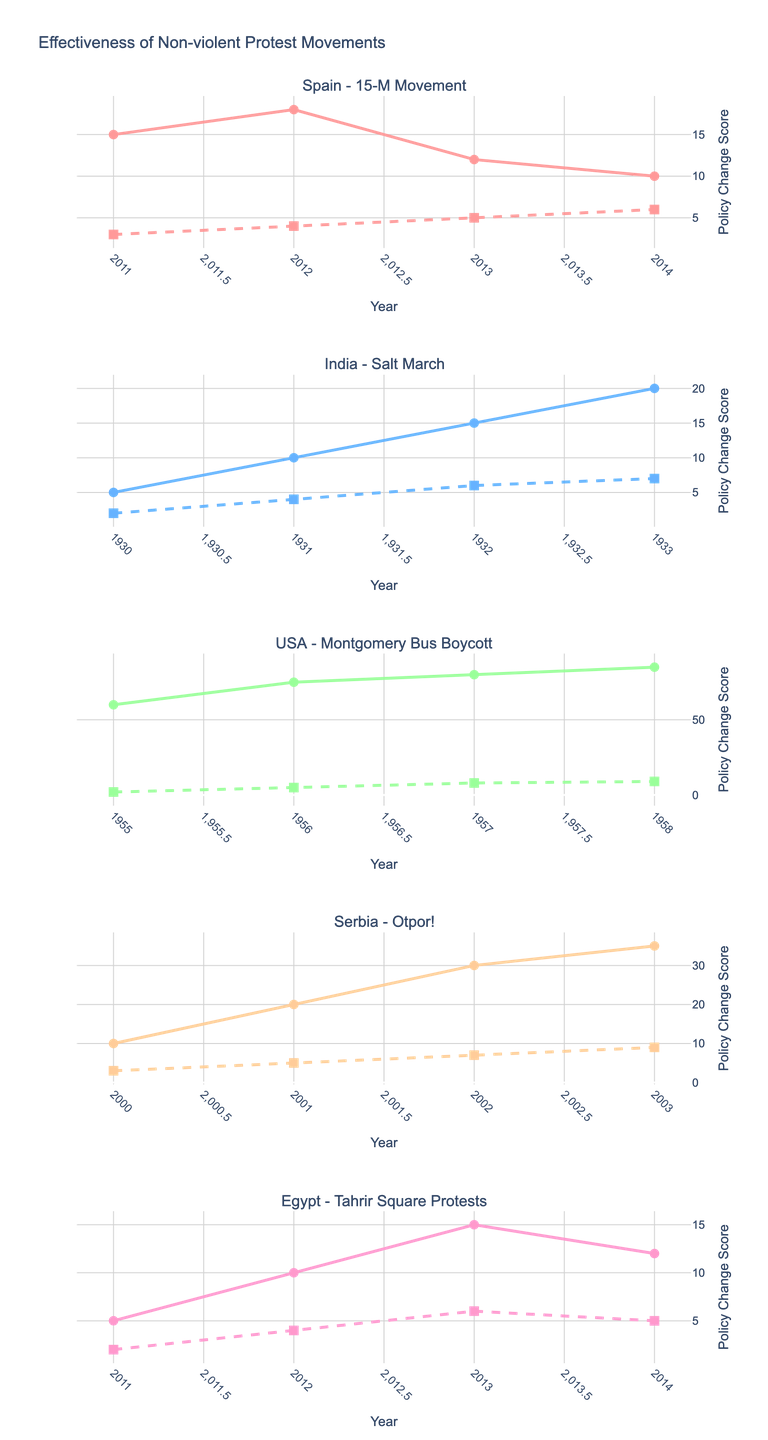¿Cuántos países se presentan en la figura? Observando los subtítulos de los subplots, se nota un país diferente mencionado en cada uno. Los subplots contienen datos sobre cinco países diferentes: España, India, EE. UU., Serbia y Egipto.
Answer: Cinco ¿Cuál es el título del subplot para Serbia? Cada subplot tiene un título que combina el nombre del país y el nombre del movimiento. El título para el subplot de Serbia es "Serbia - Otpor!".
Answer: Serbia - Otpor! ¿Qué año muestra la mayor tasa de participación para el Movimiento 15-M en España? Para identificar esto, observa la línea de la tasa de participación en el subplot de España. La tasa más alta es en el año 2012 con una tasa del 18%.
Answer: 2012 ¿Cuál fue la mayor puntuación de cambio de políticas durante las protestas en la Plaza Tahrir en Egipto? Al revisar la línea de la puntuación de cambio de políticas en el subplot para Egipto, la mayor puntuación es 6 en el año 2013.
Answer: 6 ¿Cuál es la diferencia en la tasa de participación entre 1931 y 1933 durante la Marcha de la Sal en India? Observando el subplot de India, la tasa de participación en 1931 fue del 10% y en 1933 fue del 20%. La diferencia es 20% - 10% = 10%.
Answer: 10% ¿Cómo se comparan las tasas de participación en el primer año (2011) y el último año (2014) del Movimiento 15-M en España? La tasa de participación en España fue del 15% en 2011 y del 10% en 2014. Comparando estos valores, la tasa disminuyó del 15% al 10%.
Answer: Disminuyó ¿Cuál movimiento tuvo la mayor participación en el primer año de protesta? En el subplot de EE. UU. sobre el boicot a los autobuses de Montgomery, la participación fue del 60% en 1955, lo cual es la más alta entre todas las primeras participaciones en los subplots.
Answer: Boicot a los autobuses de Montgomery Entre 2012 y 2013, ¿cómo cambió la puntuación de cambio de políticas en Egipto en comparación con la tasa de participación? En Egipto, entre 2012 y 2013, la puntuación de cambio de políticas pasó de 4 a 6 (un aumento de 2), mientras que la tasa de participación aumentó de 10% a 15% (un aumento de 5%). Ambas métricas aumentaron.
Answer: Aumentaron ¿Cuántos años muestra cada subplot? En cada subplot, se visualizan eventos que ocurrieron a lo largo de cuatro años. Observa que hay cuatro puntos en cada línea de cada subplot.
Answer: Cuatro 